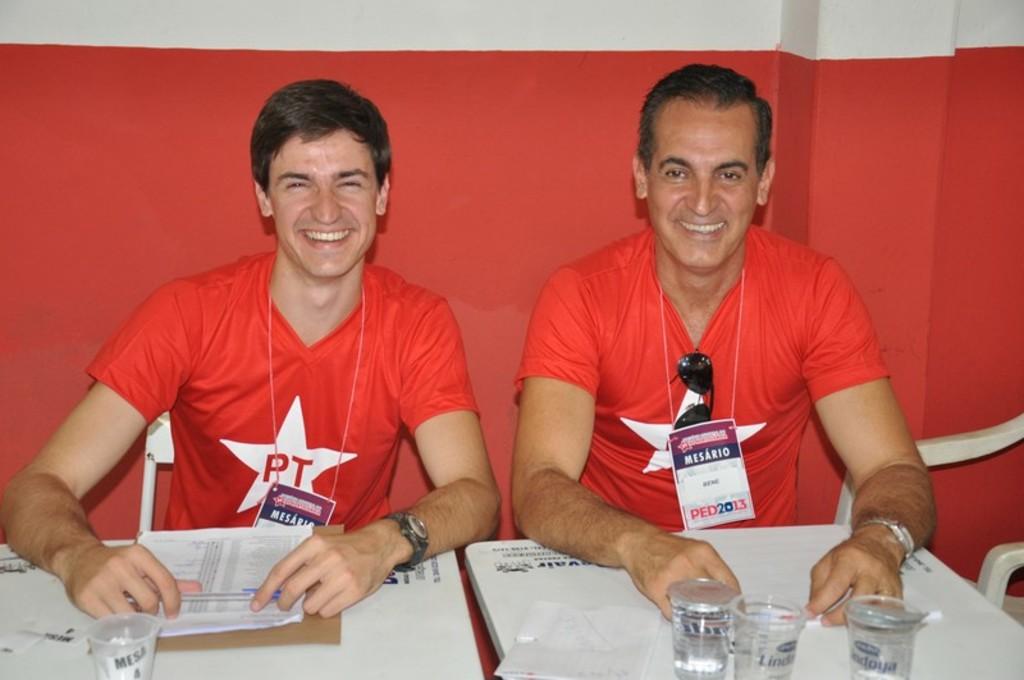What year is shown on the man's lanyard badge?
Provide a succinct answer. 2013. 